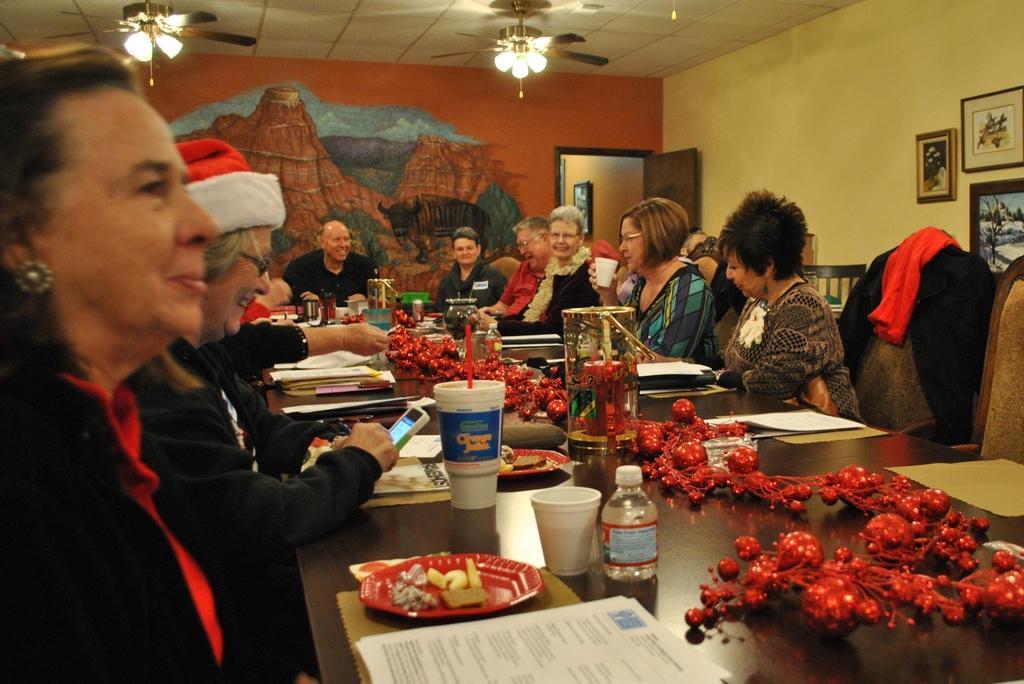Describe this image in one or two sentences. In this image, we can see people sitting on the chairs and some are wearing glasses and coats and one of them is wearing a cap and holding a mobile and we can see some clothes on the chair. At the bottom, there are bottles, cups, paper, plates and some food items and some other objects on the table. In the background, there are lights and some frames on the wall and there is a door. 